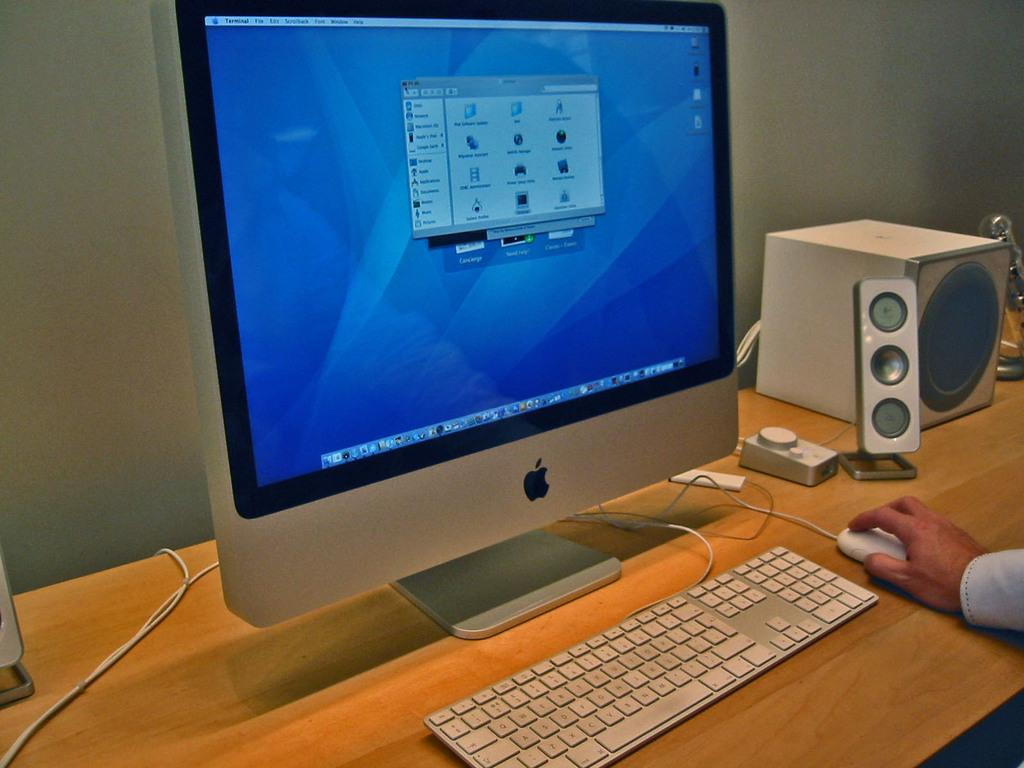What is the main object in the foreground of the image? There is a computer in the foreground area of the image. Where is the computer placed? The computer is on a desk. What other electronic devices are visible in the image? There are speakers in the image. What is the person in the image doing with their hand? A hand is on the mouse. On which side of the image is the mouse located? The mouse is on the right side of the image. What type of bubble can be seen floating near the computer in the image? There is no bubble present in the image; it only features a computer, speakers, a desk, a hand on the mouse, and the mouse itself. Is there a sofa visible in the image? No, there is no sofa present in the image. 